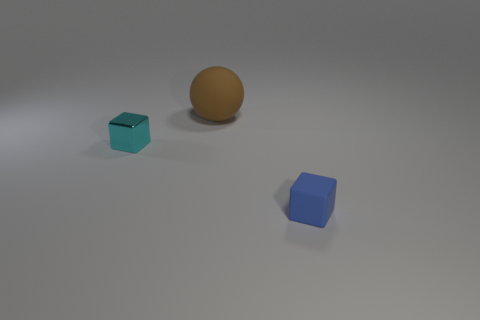Are there any other things that have the same material as the small cyan block?
Offer a very short reply. No. Are there more rubber things than objects?
Offer a very short reply. No. Are there any tiny objects to the left of the matte object on the right side of the brown matte ball?
Provide a succinct answer. Yes. Is the number of large brown spheres left of the large rubber thing less than the number of big brown things that are behind the blue matte block?
Your answer should be compact. Yes. Are the blue cube in front of the large object and the large brown sphere on the left side of the small matte block made of the same material?
Offer a very short reply. Yes. What number of tiny things are cyan metal things or brown spheres?
Ensure brevity in your answer.  1. There is a large brown thing that is the same material as the blue object; what is its shape?
Your answer should be very brief. Sphere. Are there fewer large brown things to the right of the tiny blue rubber object than large cyan matte cylinders?
Your answer should be compact. No. Is the brown matte thing the same shape as the small cyan object?
Ensure brevity in your answer.  No. How many shiny objects are either brown cylinders or brown things?
Keep it short and to the point. 0. 